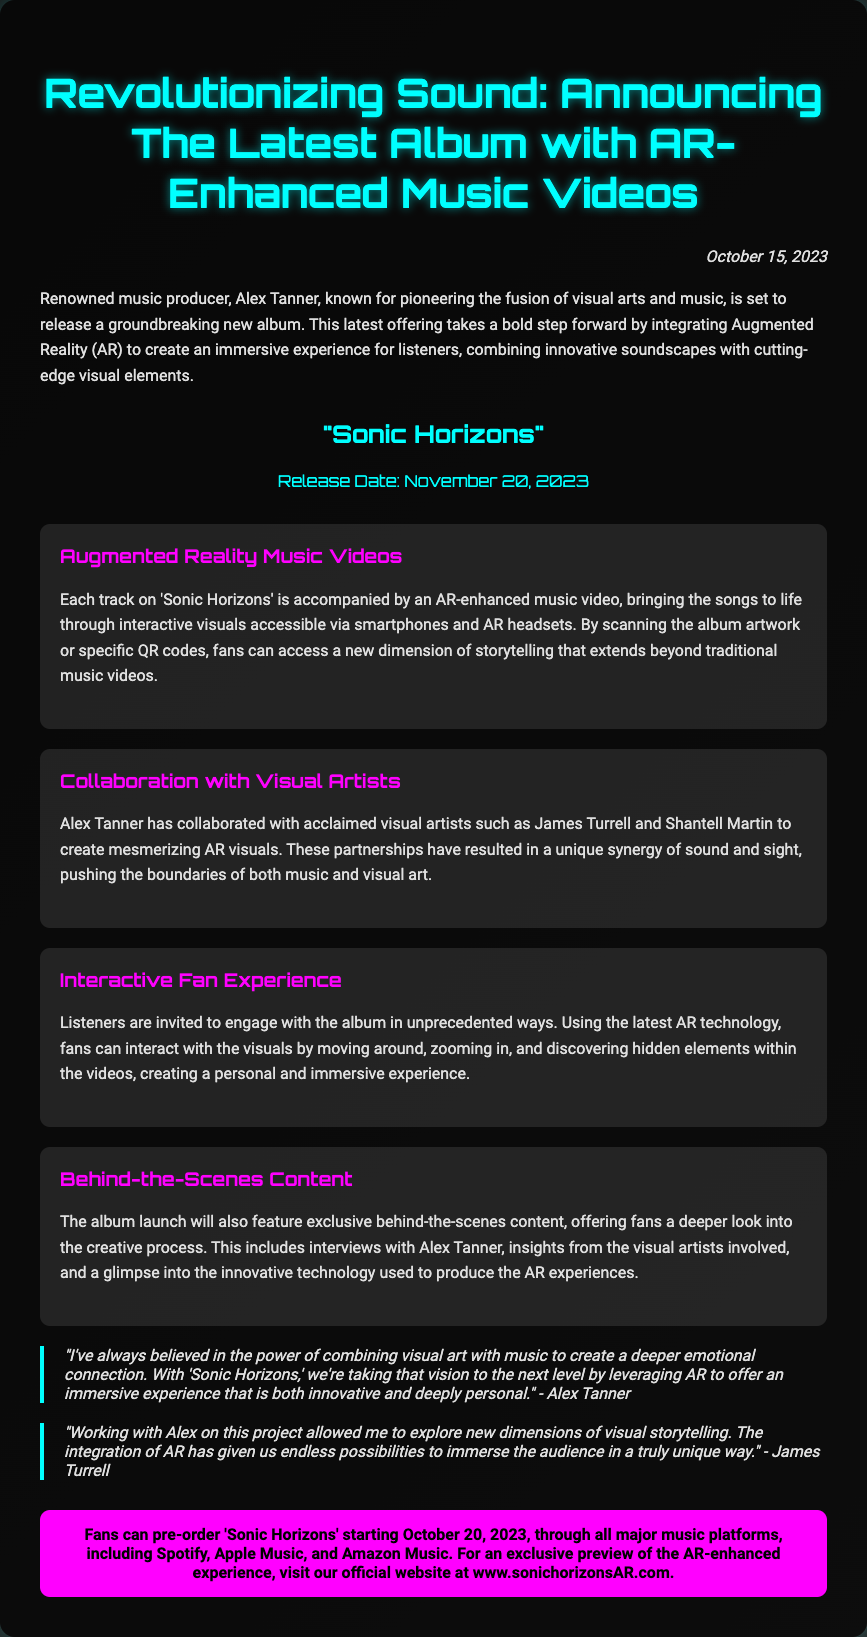What is the title of the new album? The title of the new album is mentioned explicitly in the document.
Answer: "Sonic Horizons" Who is the renowned music producer behind this album? The document identifies the music producer who is releasing the album.
Answer: Alex Tanner When will the album be released? The release date of the album is provided in the document.
Answer: November 20, 2023 What technology is integrated into the album's music videos? The document describes the innovative technology used in the music videos.
Answer: Augmented Reality (AR) Name one visual artist collaborated with Alex Tanner. The document mentions several visual artists, allowing identification of at least one.
Answer: James Turrell What date can fans pre-order the album? The pre-order date for the album is specified in the document.
Answer: October 20, 2023 What type of experience does the album offer to listeners? The document describes the nature of the experience created by the album.
Answer: Immersive experience What is the official website for the album? The document provides the URL for fans to visit for an exclusive preview.
Answer: www.sonichorizonsAR.com What is a feature of the AR-enhanced music videos? The document highlights a specific aspect of the AR videos.
Answer: Interactive visuals 